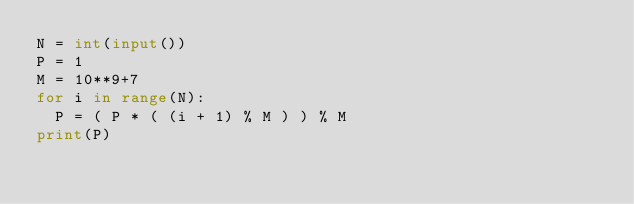Convert code to text. <code><loc_0><loc_0><loc_500><loc_500><_Python_>N = int(input())
P = 1
M = 10**9+7
for i in range(N):
  P = ( P * ( (i + 1) % M ) ) % M
print(P)</code> 